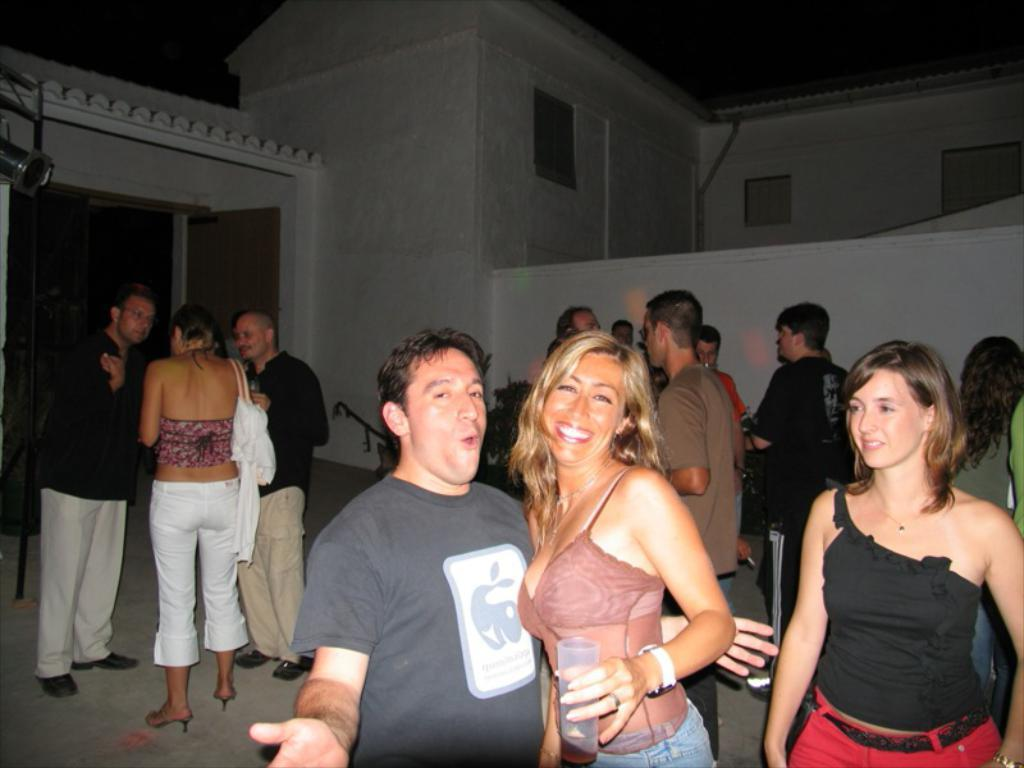How many people are present in the image? There is a man and a woman in the image. What is the woman wearing in the image? The woman is wearing a black top. What can be seen in the background of the image? There are many people and a white building in the background of the image. What is the color of the building in the background? The building in the background is white. What type of stick can be seen in the woman's hand in the image? There is no stick present in the woman's hand or anywhere in the image. What flavor of mint is being consumed by the man in the image? There is no mint or any indication of the man consuming anything in the image. 